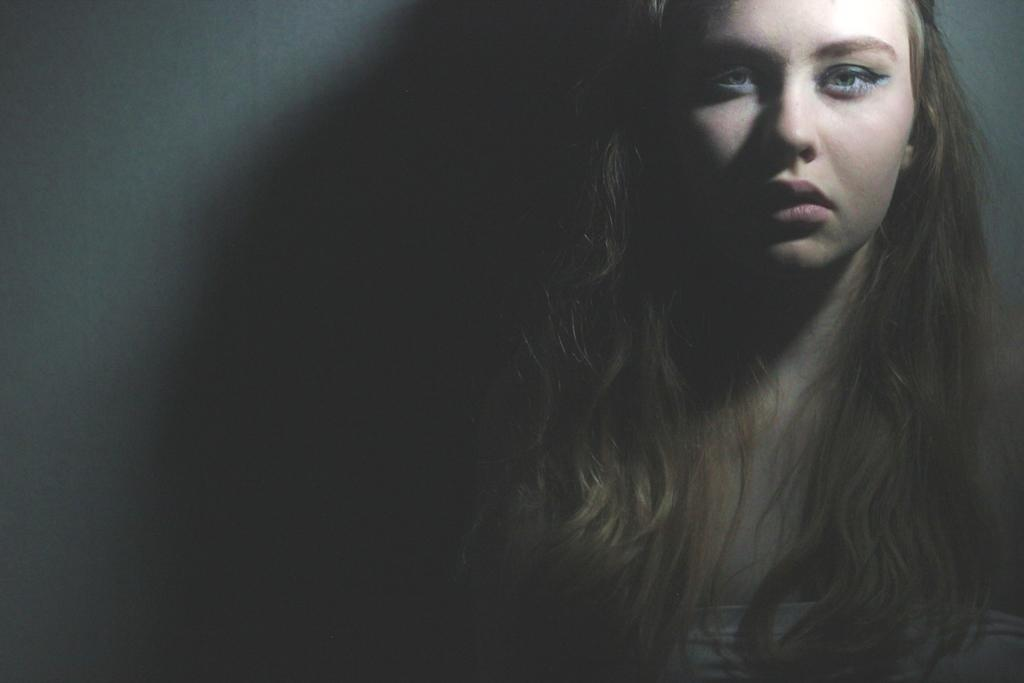What is the lighting condition in the image? The image is taken in a dark environment. Can you describe the person in the image? There is a woman in the image. Where is the woman positioned in the image? The woman is standing near a wall. Reasoning: Let's think step by breaking down the conversation step by step. We start by addressing the lighting condition, which is mentioned as a fact. Then, we move on to describe the person in the image, which is the woman. Finally, we focus on her positioning, stating that she is standing near a wall. Each question is designed to elicit a specific detail about the image that is known from the provided facts. Absurd Question/Answer: Is the woman wearing a mask in the image? There is no mention of a mask in the image, so we cannot determine if the woman is wearing one. How does the ice cream move around in the image? The ice cream does not move around in the image; it is stationary in the bowl. --- Facts: 1. The image is taken in a dark environment. 2. There is a woman in the image. 3. The woman is standing near a wall. Absurd Topics: move, mask, baby Conversation: What is the lighting condition in the image? The image is taken in a dark environment. Can you describe the person in the image? There is a woman in the image. Where is the woman positioned in the image? The woman is standing near a wall. Reasoning: Let's think step by step in order to produce the conversation. We start by addressing the lighting condition, which is mentioned as a fact. Then, we move on to describe the person in the image, which is the woman. Finally, we focus on her positioning, stating that she is standing near a wall. Each question is designed to elicit a specific detail about the image that is known from the provided facts. Absurd Question/Answer: Is the woman wearing a mask in the image? There is no mention of a mask in the image, so we cannot determine if the woman is wearing one. 